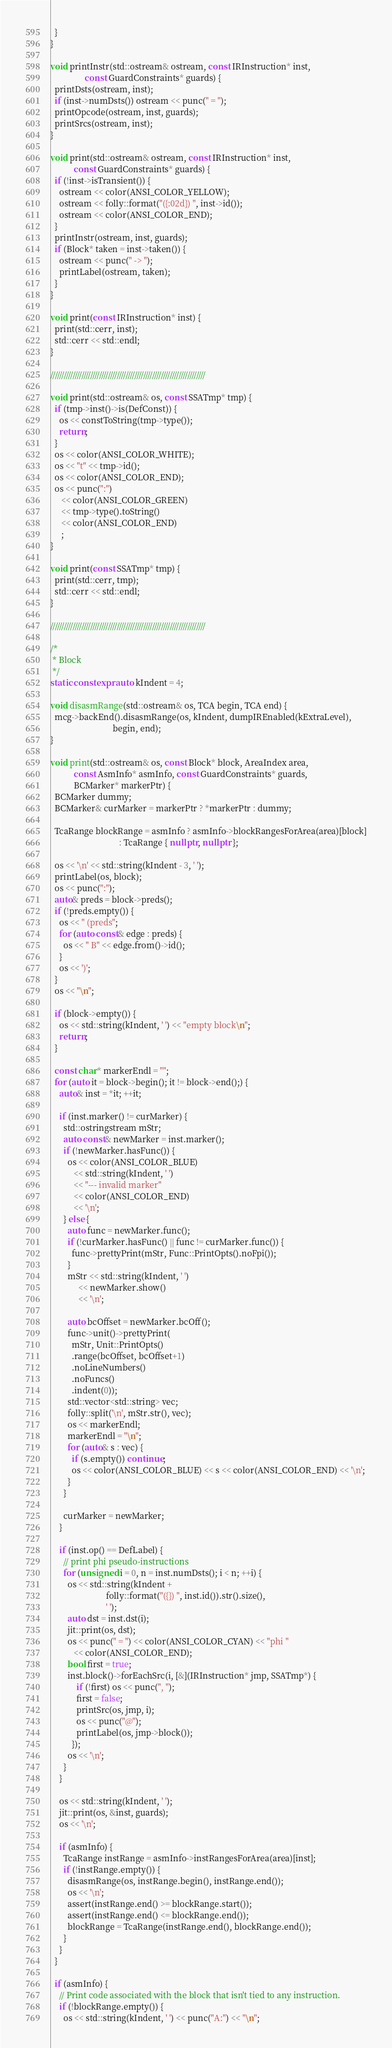Convert code to text. <code><loc_0><loc_0><loc_500><loc_500><_C++_>  }
}

void printInstr(std::ostream& ostream, const IRInstruction* inst,
                const GuardConstraints* guards) {
  printDsts(ostream, inst);
  if (inst->numDsts()) ostream << punc(" = ");
  printOpcode(ostream, inst, guards);
  printSrcs(ostream, inst);
}

void print(std::ostream& ostream, const IRInstruction* inst,
           const GuardConstraints* guards) {
  if (!inst->isTransient()) {
    ostream << color(ANSI_COLOR_YELLOW);
    ostream << folly::format("({:02d}) ", inst->id());
    ostream << color(ANSI_COLOR_END);
  }
  printInstr(ostream, inst, guards);
  if (Block* taken = inst->taken()) {
    ostream << punc(" -> ");
    printLabel(ostream, taken);
  }
}

void print(const IRInstruction* inst) {
  print(std::cerr, inst);
  std::cerr << std::endl;
}

//////////////////////////////////////////////////////////////////////

void print(std::ostream& os, const SSATmp* tmp) {
  if (tmp->inst()->is(DefConst)) {
    os << constToString(tmp->type());
    return;
  }
  os << color(ANSI_COLOR_WHITE);
  os << "t" << tmp->id();
  os << color(ANSI_COLOR_END);
  os << punc(":")
     << color(ANSI_COLOR_GREEN)
     << tmp->type().toString()
     << color(ANSI_COLOR_END)
     ;
}

void print(const SSATmp* tmp) {
  print(std::cerr, tmp);
  std::cerr << std::endl;
}

//////////////////////////////////////////////////////////////////////

/*
 * Block
 */
static constexpr auto kIndent = 4;

void disasmRange(std::ostream& os, TCA begin, TCA end) {
  mcg->backEnd().disasmRange(os, kIndent, dumpIREnabled(kExtraLevel),
                             begin, end);
}

void print(std::ostream& os, const Block* block, AreaIndex area,
           const AsmInfo* asmInfo, const GuardConstraints* guards,
           BCMarker* markerPtr) {
  BCMarker dummy;
  BCMarker& curMarker = markerPtr ? *markerPtr : dummy;

  TcaRange blockRange = asmInfo ? asmInfo->blockRangesForArea(area)[block]
                                : TcaRange { nullptr, nullptr };

  os << '\n' << std::string(kIndent - 3, ' ');
  printLabel(os, block);
  os << punc(":");
  auto& preds = block->preds();
  if (!preds.empty()) {
    os << " (preds";
    for (auto const& edge : preds) {
      os << " B" << edge.from()->id();
    }
    os << ')';
  }
  os << "\n";

  if (block->empty()) {
    os << std::string(kIndent, ' ') << "empty block\n";
    return;
  }

  const char* markerEndl = "";
  for (auto it = block->begin(); it != block->end();) {
    auto& inst = *it; ++it;

    if (inst.marker() != curMarker) {
      std::ostringstream mStr;
      auto const& newMarker = inst.marker();
      if (!newMarker.hasFunc()) {
        os << color(ANSI_COLOR_BLUE)
           << std::string(kIndent, ' ')
           << "--- invalid marker"
           << color(ANSI_COLOR_END)
           << '\n';
      } else {
        auto func = newMarker.func();
        if (!curMarker.hasFunc() || func != curMarker.func()) {
          func->prettyPrint(mStr, Func::PrintOpts().noFpi());
        }
        mStr << std::string(kIndent, ' ')
             << newMarker.show()
             << '\n';

        auto bcOffset = newMarker.bcOff();
        func->unit()->prettyPrint(
          mStr, Unit::PrintOpts()
          .range(bcOffset, bcOffset+1)
          .noLineNumbers()
          .noFuncs()
          .indent(0));
        std::vector<std::string> vec;
        folly::split('\n', mStr.str(), vec);
        os << markerEndl;
        markerEndl = "\n";
        for (auto& s : vec) {
          if (s.empty()) continue;
          os << color(ANSI_COLOR_BLUE) << s << color(ANSI_COLOR_END) << '\n';
        }
      }

      curMarker = newMarker;
    }

    if (inst.op() == DefLabel) {
      // print phi pseudo-instructions
      for (unsigned i = 0, n = inst.numDsts(); i < n; ++i) {
        os << std::string(kIndent +
                          folly::format("({}) ", inst.id()).str().size(),
                          ' ');
        auto dst = inst.dst(i);
        jit::print(os, dst);
        os << punc(" = ") << color(ANSI_COLOR_CYAN) << "phi "
           << color(ANSI_COLOR_END);
        bool first = true;
        inst.block()->forEachSrc(i, [&](IRInstruction* jmp, SSATmp*) {
            if (!first) os << punc(", ");
            first = false;
            printSrc(os, jmp, i);
            os << punc("@");
            printLabel(os, jmp->block());
          });
        os << '\n';
      }
    }

    os << std::string(kIndent, ' ');
    jit::print(os, &inst, guards);
    os << '\n';

    if (asmInfo) {
      TcaRange instRange = asmInfo->instRangesForArea(area)[inst];
      if (!instRange.empty()) {
        disasmRange(os, instRange.begin(), instRange.end());
        os << '\n';
        assert(instRange.end() >= blockRange.start());
        assert(instRange.end() <= blockRange.end());
        blockRange = TcaRange(instRange.end(), blockRange.end());
      }
    }
  }

  if (asmInfo) {
    // Print code associated with the block that isn't tied to any instruction.
    if (!blockRange.empty()) {
      os << std::string(kIndent, ' ') << punc("A:") << "\n";</code> 